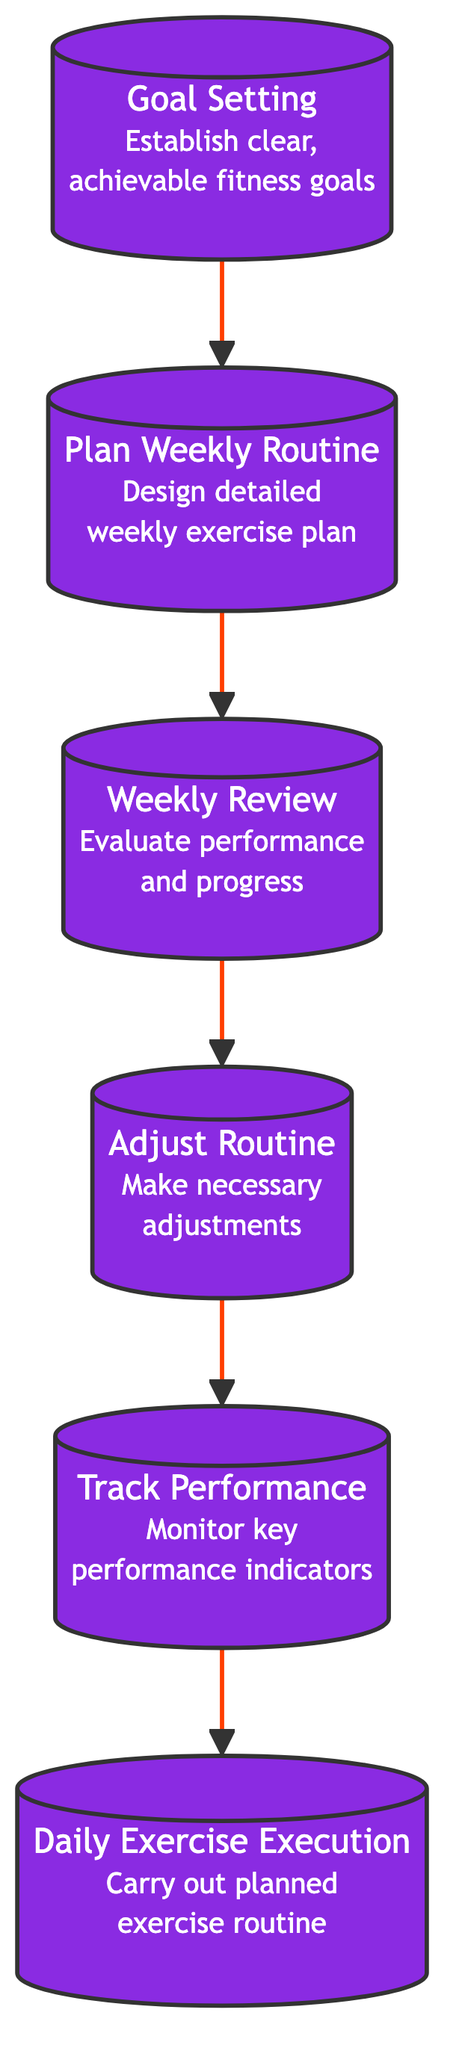What is the first step in the flowchart? The flowchart starts with "Goal Setting," which is the first node.
Answer: Goal Setting How many nodes are in the flowchart? The flowchart contains six nodes: Goal Setting, Plan Weekly Routine, Weekly Review, Adjust Routine, Track Performance, and Daily Exercise Execution.
Answer: Six What comes after "Track Performance"? After "Track Performance," the next step is "Daily Exercise Execution."
Answer: Daily Exercise Execution Which process involves evaluating performance and progress? The process that involves evaluating performance and progress is "Weekly Review."
Answer: Weekly Review What is the last step in this flowchart? The last step in the flowchart is "Daily Exercise Execution."
Answer: Daily Exercise Execution If you complete the "Weekly Review," what is the next action you should take? After completing the "Weekly Review," the next action is to "Adjust Routine."
Answer: Adjust Routine Which nodes are connected directly to "Plan Weekly Routine"? "Plan Weekly Routine" is directly connected to "Goal Setting" (before it) and "Weekly Review" (after it).
Answer: Goal Setting, Weekly Review How does "Adjust Routine" relate to "Track Performance"? "Adjust Routine" comes before "Track Performance," suggesting it is an integral step to modify the approach based on performance metrics.
Answer: It precedes it What is required for "Goal Setting" to be effective? For "Goal Setting" to be effective, clear, achievable fitness goals need to be established.
Answer: Clear, achievable fitness goals 